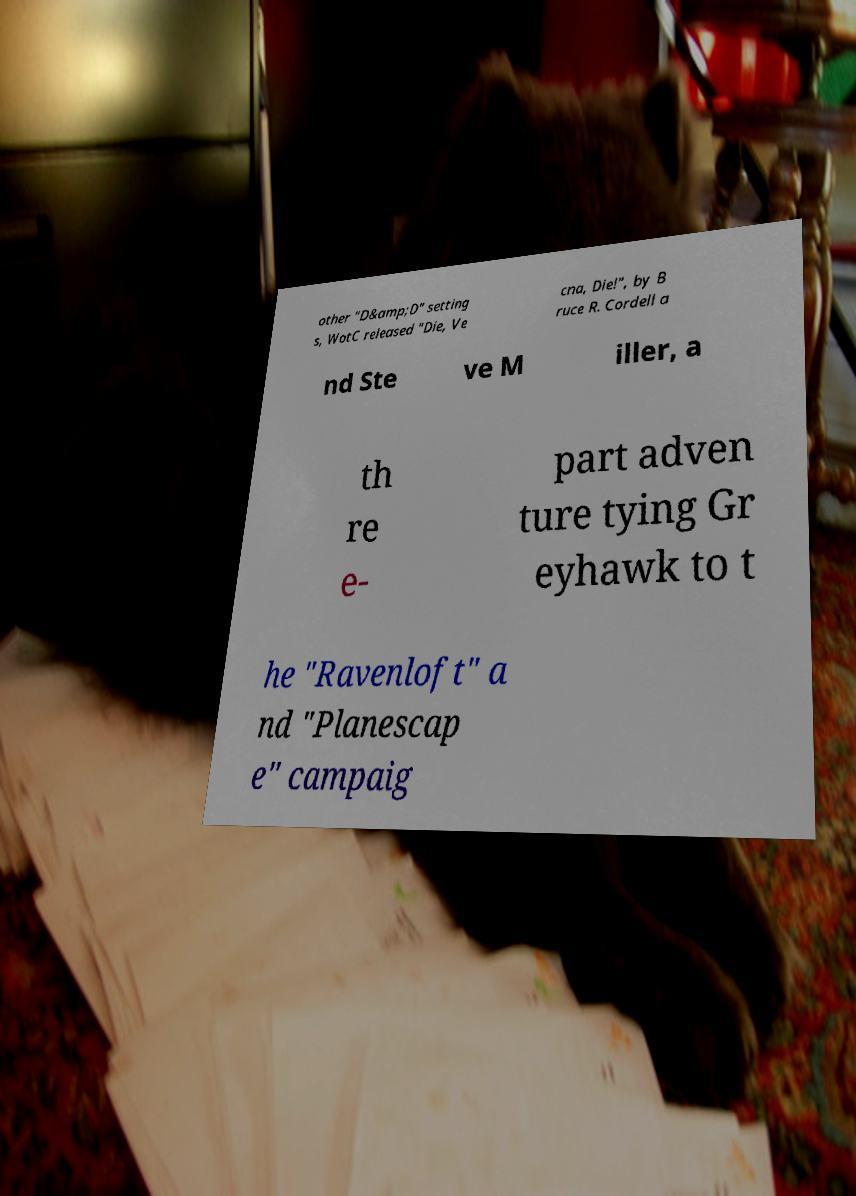Can you read and provide the text displayed in the image?This photo seems to have some interesting text. Can you extract and type it out for me? other "D&amp;D" setting s, WotC released "Die, Ve cna, Die!", by B ruce R. Cordell a nd Ste ve M iller, a th re e- part adven ture tying Gr eyhawk to t he "Ravenloft" a nd "Planescap e" campaig 